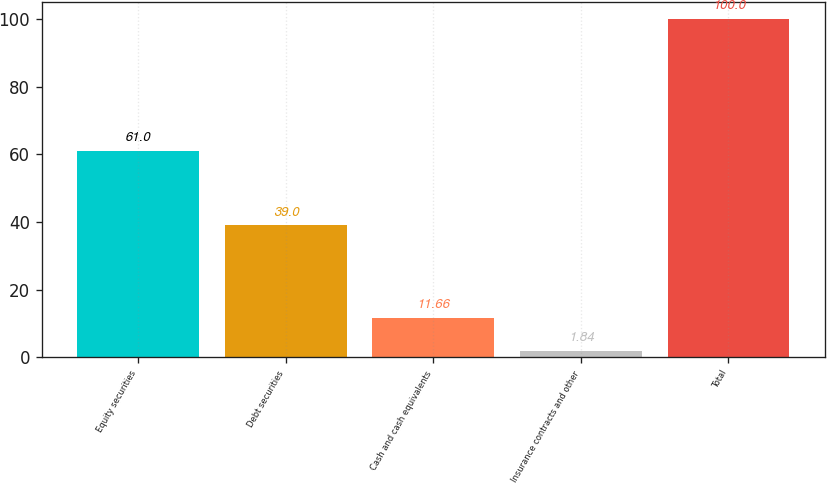Convert chart to OTSL. <chart><loc_0><loc_0><loc_500><loc_500><bar_chart><fcel>Equity securities<fcel>Debt securities<fcel>Cash and cash equivalents<fcel>Insurance contracts and other<fcel>Total<nl><fcel>61<fcel>39<fcel>11.66<fcel>1.84<fcel>100<nl></chart> 